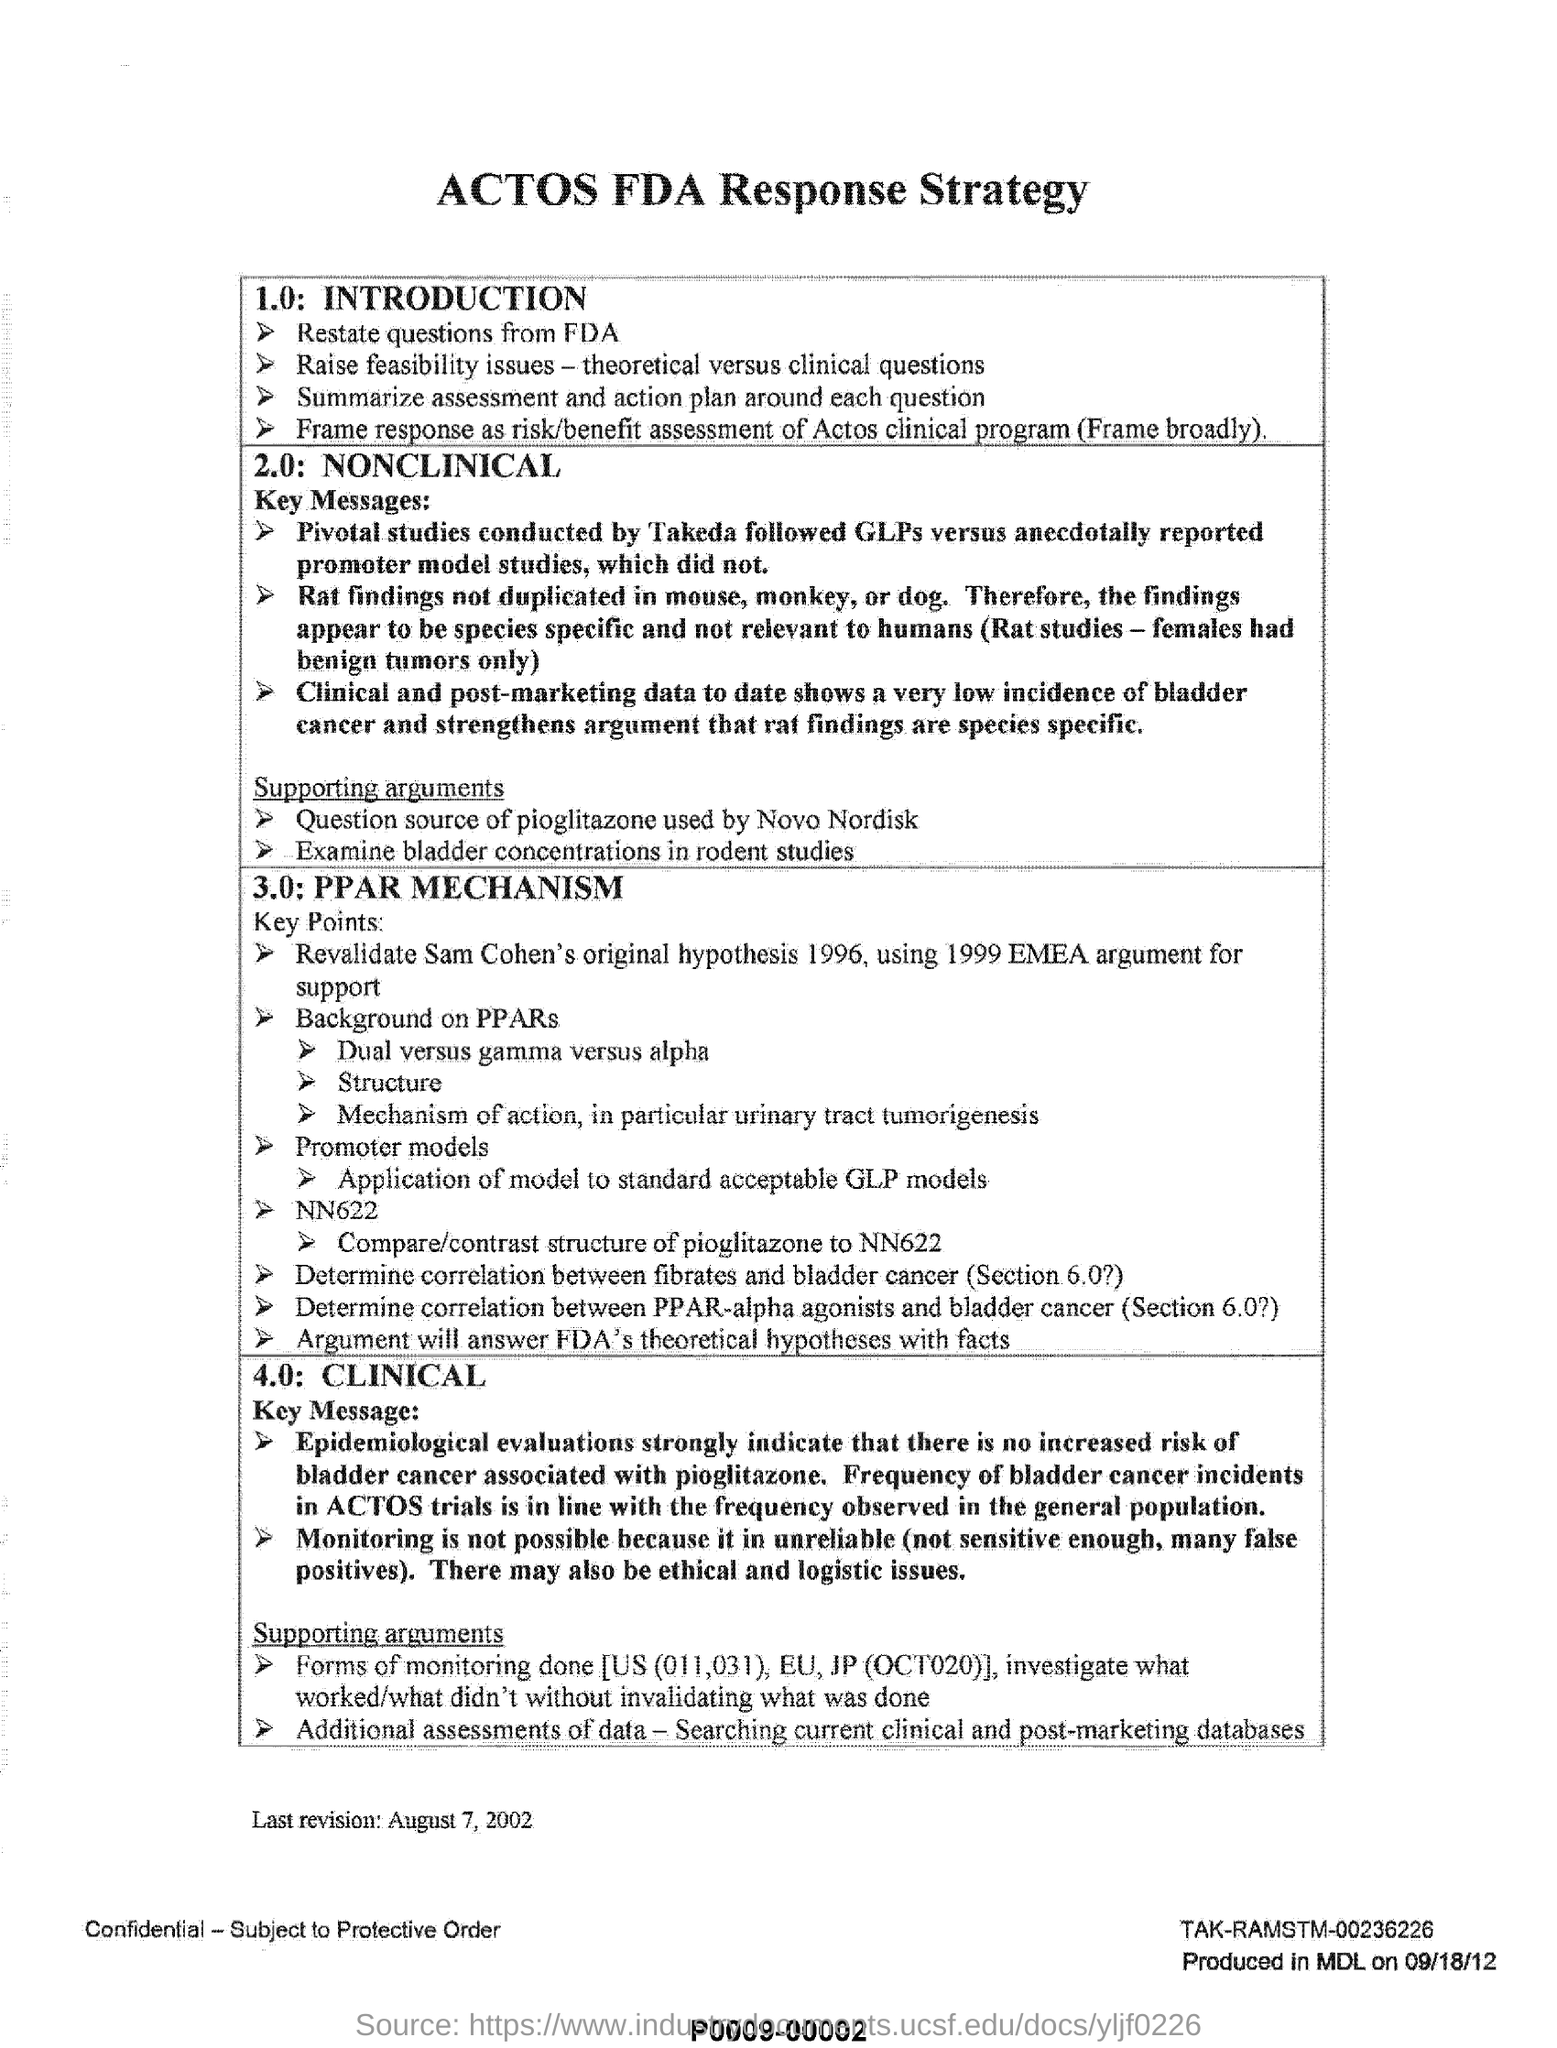Give some essential details in this illustration. The findings regarding the effects of test compound on gene expression in rats were not duplicated in studies conducted on mice, monkeys, or dogs. A pivotal study was conducted by Takeda. 